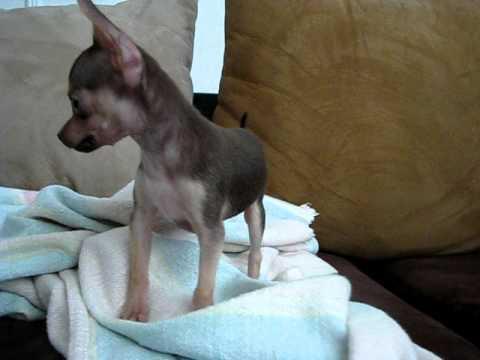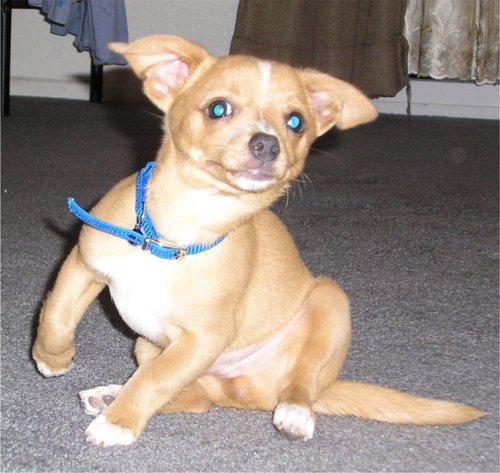The first image is the image on the left, the second image is the image on the right. Evaluate the accuracy of this statement regarding the images: "There are more dogs in the image on the right.". Is it true? Answer yes or no. No. The first image is the image on the left, the second image is the image on the right. Examine the images to the left and right. Is the description "All chihuahuas pictured are wearing at least collars, and each image includes at least one standing chihuahua." accurate? Answer yes or no. No. 